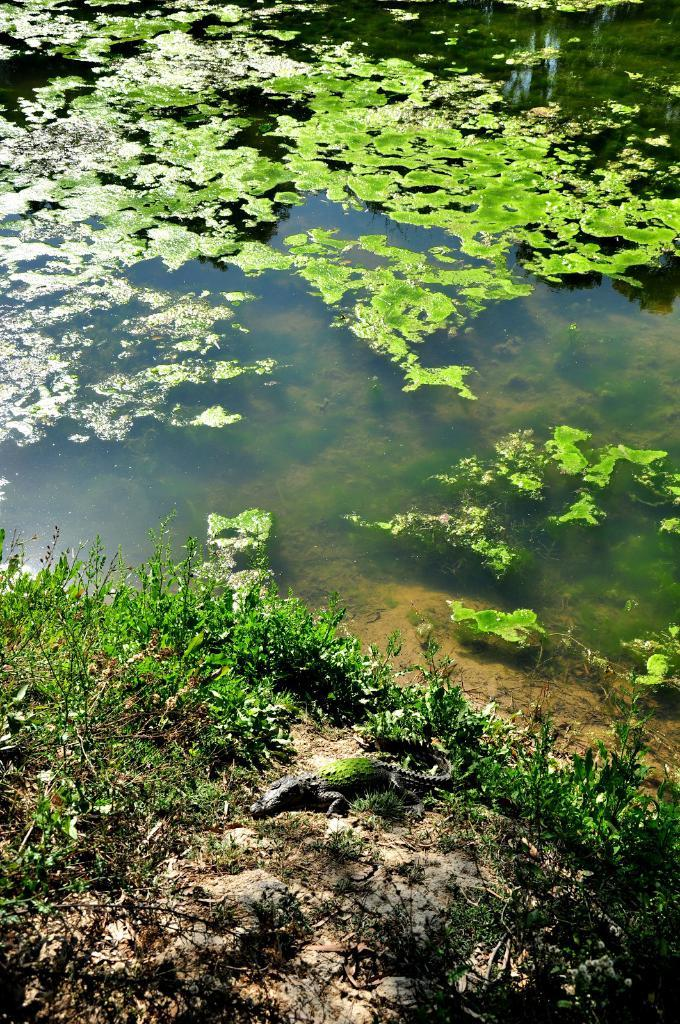What animal is on the ground in the image? There is a crocodile on the ground in the image. What type of vegetation can be seen in the image? There are plants in the image. What can be seen at the top of the image? There is water visible at the top of the image. What color is the rose in the image? There is no rose present in the image. How does the crocodile feel about its actions in the image? The image does not convey any emotions or feelings of the crocodile, so we cannot determine how it feels about its actions. 